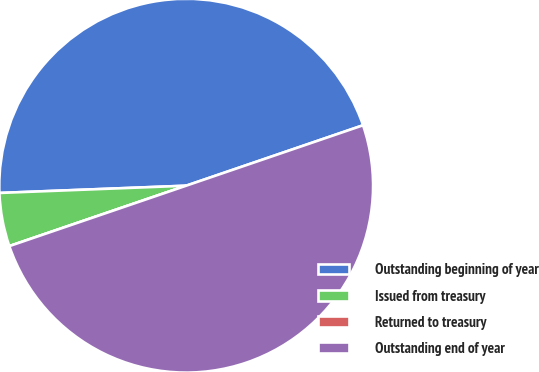Convert chart to OTSL. <chart><loc_0><loc_0><loc_500><loc_500><pie_chart><fcel>Outstanding beginning of year<fcel>Issued from treasury<fcel>Returned to treasury<fcel>Outstanding end of year<nl><fcel>45.38%<fcel>4.62%<fcel>0.0%<fcel>50.0%<nl></chart> 